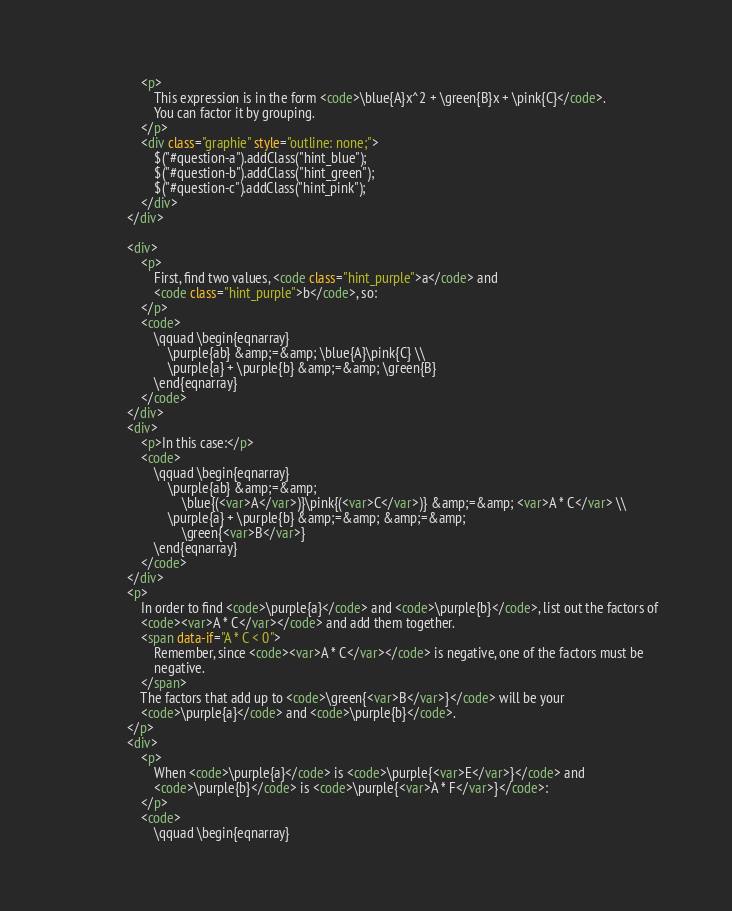Convert code to text. <code><loc_0><loc_0><loc_500><loc_500><_HTML_>                    <p>
                        This expression is in the form <code>\blue{A}x^2 + \green{B}x + \pink{C}</code>.
                        You can factor it by grouping.
                    </p>
                    <div class="graphie" style="outline: none;">
                        $("#question-a").addClass("hint_blue");
                        $("#question-b").addClass("hint_green");
                        $("#question-c").addClass("hint_pink");
                    </div>
                </div>

                <div>
                    <p>
                        First, find two values, <code class="hint_purple">a</code> and
                        <code class="hint_purple">b</code>, so:
                    </p>
                    <code>
                        \qquad \begin{eqnarray}
                            \purple{ab} &amp;=&amp; \blue{A}\pink{C} \\
                            \purple{a} + \purple{b} &amp;=&amp; \green{B}
                        \end{eqnarray}
                    </code>
                </div>
                <div>
                    <p>In this case:</p>
                    <code>
                        \qquad \begin{eqnarray}
                            \purple{ab} &amp;=&amp;
                                \blue{(<var>A</var>)}\pink{(<var>C</var>)} &amp;=&amp; <var>A * C</var> \\
                            \purple{a} + \purple{b} &amp;=&amp; &amp;=&amp;
                                \green{<var>B</var>}
                        \end{eqnarray}
                    </code>
                </div>
                <p>
                    In order to find <code>\purple{a}</code> and <code>\purple{b}</code>, list out the factors of
                    <code><var>A * C</var></code> and add them together.
                    <span data-if="A * C < 0">
                        Remember, since <code><var>A * C</var></code> is negative, one of the factors must be
                        negative.
                    </span>
                    The factors that add up to <code>\green{<var>B</var>}</code> will be your
                    <code>\purple{a}</code> and <code>\purple{b}</code>.
                </p>
                <div>
                    <p>
                        When <code>\purple{a}</code> is <code>\purple{<var>E</var>}</code> and
                        <code>\purple{b}</code> is <code>\purple{<var>A * F</var>}</code>:
                    </p>
                    <code>
                        \qquad \begin{eqnarray}</code> 